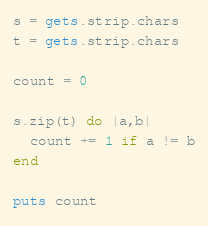Convert code to text. <code><loc_0><loc_0><loc_500><loc_500><_Ruby_>s = gets.strip.chars
t = gets.strip.chars

count = 0

s.zip(t) do |a,b|
  count += 1 if a != b
end

puts count
</code> 